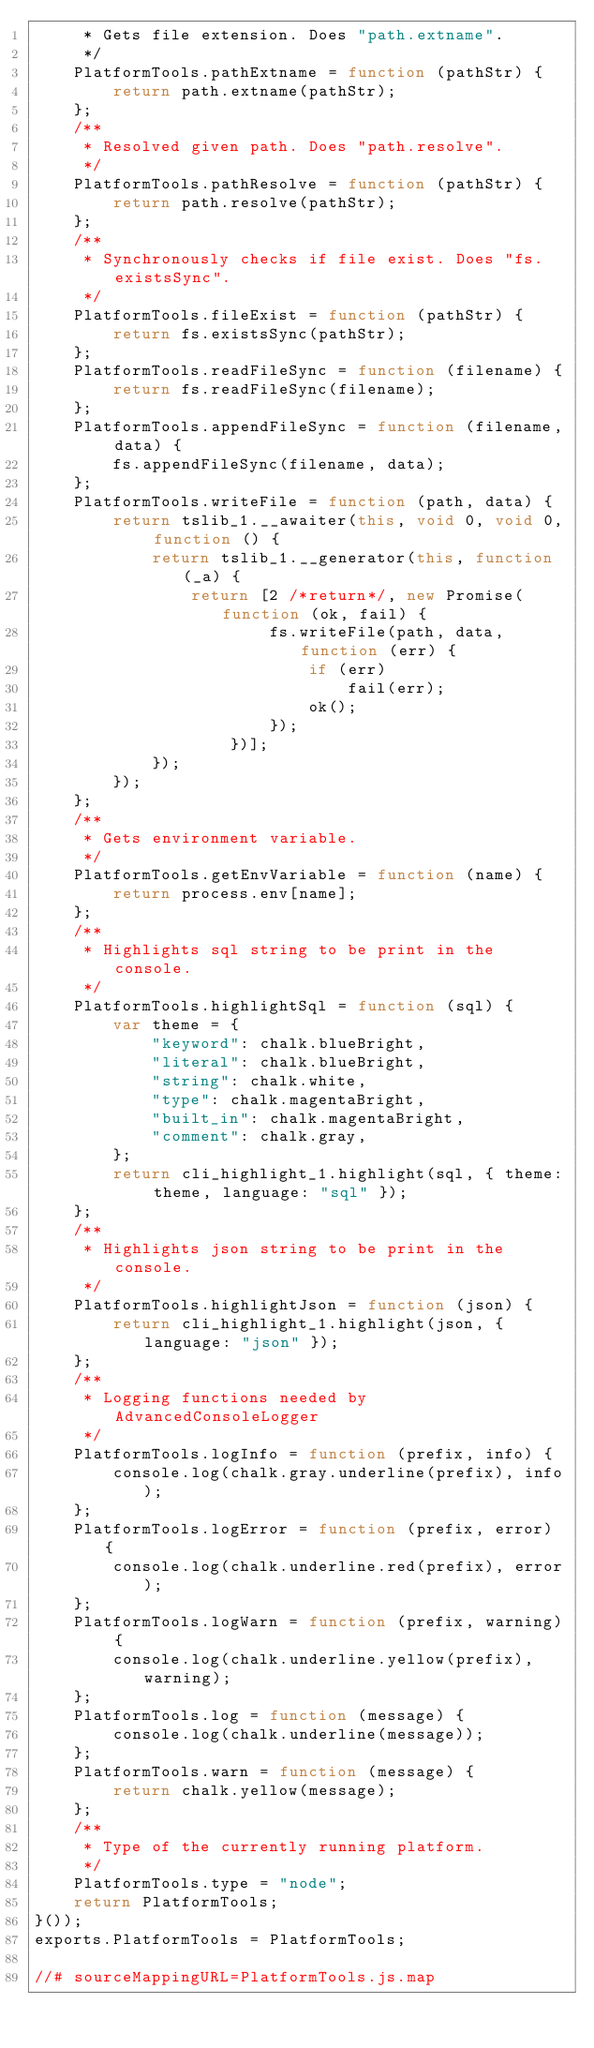Convert code to text. <code><loc_0><loc_0><loc_500><loc_500><_JavaScript_>     * Gets file extension. Does "path.extname".
     */
    PlatformTools.pathExtname = function (pathStr) {
        return path.extname(pathStr);
    };
    /**
     * Resolved given path. Does "path.resolve".
     */
    PlatformTools.pathResolve = function (pathStr) {
        return path.resolve(pathStr);
    };
    /**
     * Synchronously checks if file exist. Does "fs.existsSync".
     */
    PlatformTools.fileExist = function (pathStr) {
        return fs.existsSync(pathStr);
    };
    PlatformTools.readFileSync = function (filename) {
        return fs.readFileSync(filename);
    };
    PlatformTools.appendFileSync = function (filename, data) {
        fs.appendFileSync(filename, data);
    };
    PlatformTools.writeFile = function (path, data) {
        return tslib_1.__awaiter(this, void 0, void 0, function () {
            return tslib_1.__generator(this, function (_a) {
                return [2 /*return*/, new Promise(function (ok, fail) {
                        fs.writeFile(path, data, function (err) {
                            if (err)
                                fail(err);
                            ok();
                        });
                    })];
            });
        });
    };
    /**
     * Gets environment variable.
     */
    PlatformTools.getEnvVariable = function (name) {
        return process.env[name];
    };
    /**
     * Highlights sql string to be print in the console.
     */
    PlatformTools.highlightSql = function (sql) {
        var theme = {
            "keyword": chalk.blueBright,
            "literal": chalk.blueBright,
            "string": chalk.white,
            "type": chalk.magentaBright,
            "built_in": chalk.magentaBright,
            "comment": chalk.gray,
        };
        return cli_highlight_1.highlight(sql, { theme: theme, language: "sql" });
    };
    /**
     * Highlights json string to be print in the console.
     */
    PlatformTools.highlightJson = function (json) {
        return cli_highlight_1.highlight(json, { language: "json" });
    };
    /**
     * Logging functions needed by AdvancedConsoleLogger
     */
    PlatformTools.logInfo = function (prefix, info) {
        console.log(chalk.gray.underline(prefix), info);
    };
    PlatformTools.logError = function (prefix, error) {
        console.log(chalk.underline.red(prefix), error);
    };
    PlatformTools.logWarn = function (prefix, warning) {
        console.log(chalk.underline.yellow(prefix), warning);
    };
    PlatformTools.log = function (message) {
        console.log(chalk.underline(message));
    };
    PlatformTools.warn = function (message) {
        return chalk.yellow(message);
    };
    /**
     * Type of the currently running platform.
     */
    PlatformTools.type = "node";
    return PlatformTools;
}());
exports.PlatformTools = PlatformTools;

//# sourceMappingURL=PlatformTools.js.map
</code> 